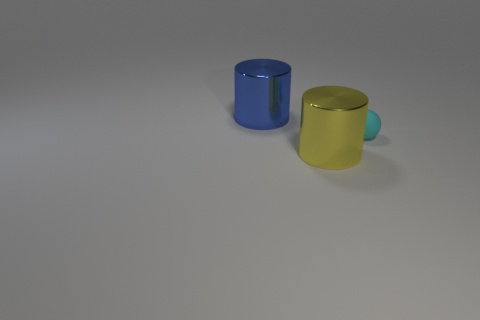Add 2 small brown cylinders. How many objects exist? 5 Subtract all cylinders. How many objects are left? 1 Subtract 1 yellow cylinders. How many objects are left? 2 Subtract all tiny red metallic cubes. Subtract all yellow shiny cylinders. How many objects are left? 2 Add 3 yellow metallic things. How many yellow metallic things are left? 4 Add 1 tiny gray cylinders. How many tiny gray cylinders exist? 1 